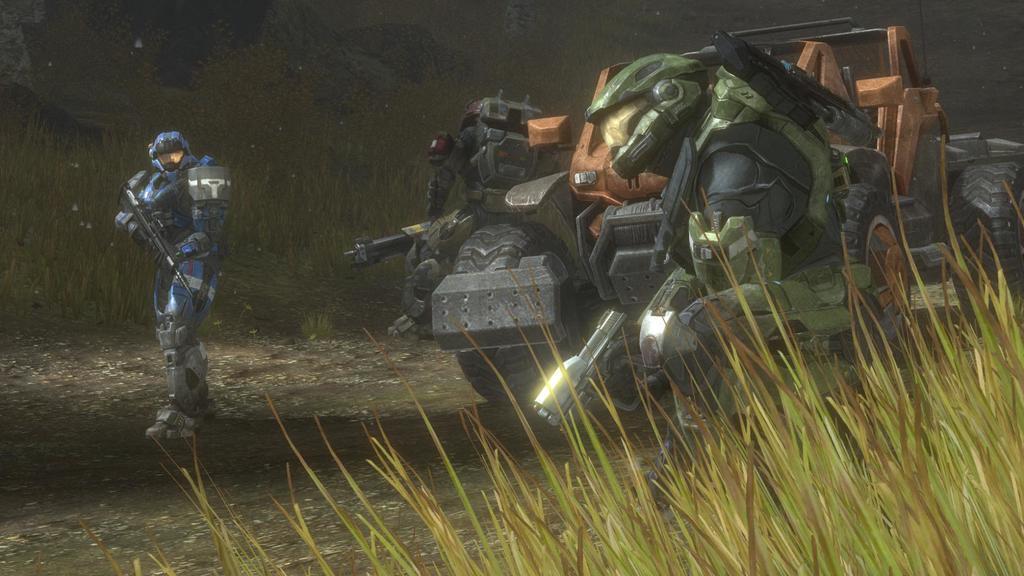Please provide a concise description of this image. In this image I see an animated picture and I see a vehicle and 3 robots and I see the grass and it is black in the background. 